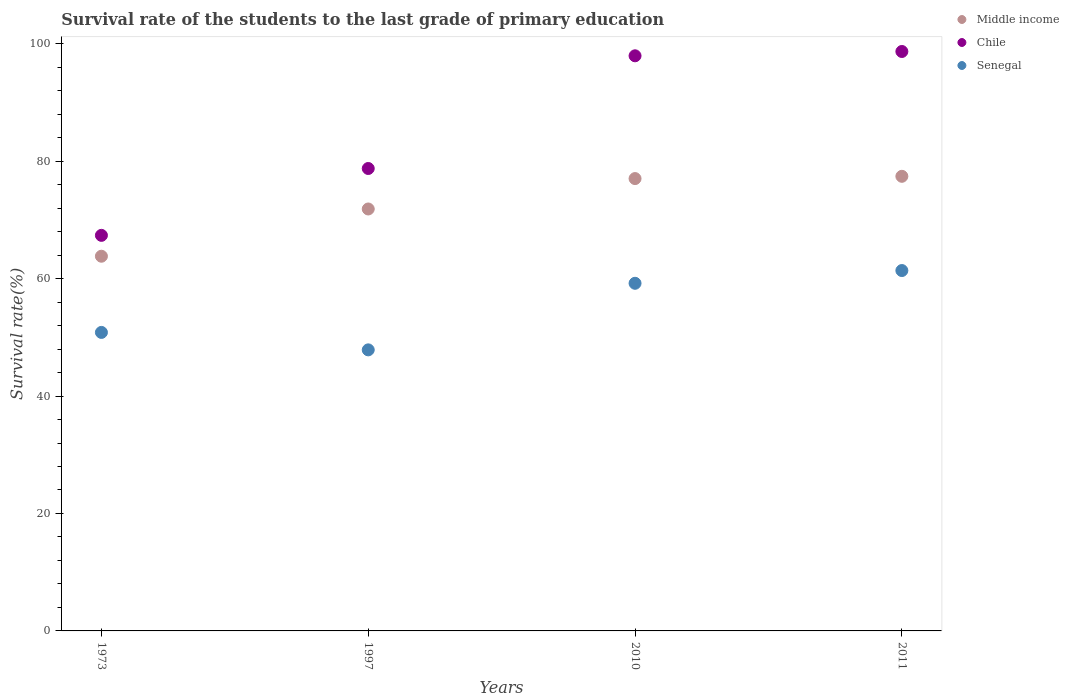What is the survival rate of the students in Middle income in 2010?
Offer a very short reply. 77.03. Across all years, what is the maximum survival rate of the students in Senegal?
Your answer should be very brief. 61.37. Across all years, what is the minimum survival rate of the students in Chile?
Your answer should be compact. 67.36. In which year was the survival rate of the students in Middle income maximum?
Provide a short and direct response. 2011. What is the total survival rate of the students in Senegal in the graph?
Offer a terse response. 219.25. What is the difference between the survival rate of the students in Chile in 1997 and that in 2010?
Offer a terse response. -19.19. What is the difference between the survival rate of the students in Chile in 1973 and the survival rate of the students in Middle income in 2010?
Provide a short and direct response. -9.67. What is the average survival rate of the students in Middle income per year?
Provide a succinct answer. 72.52. In the year 2011, what is the difference between the survival rate of the students in Senegal and survival rate of the students in Middle income?
Offer a terse response. -16.05. In how many years, is the survival rate of the students in Middle income greater than 44 %?
Ensure brevity in your answer.  4. What is the ratio of the survival rate of the students in Chile in 1997 to that in 2010?
Make the answer very short. 0.8. What is the difference between the highest and the second highest survival rate of the students in Chile?
Provide a short and direct response. 0.73. What is the difference between the highest and the lowest survival rate of the students in Senegal?
Keep it short and to the point. 13.51. In how many years, is the survival rate of the students in Middle income greater than the average survival rate of the students in Middle income taken over all years?
Your response must be concise. 2. Is the survival rate of the students in Chile strictly greater than the survival rate of the students in Middle income over the years?
Make the answer very short. Yes. Is the survival rate of the students in Chile strictly less than the survival rate of the students in Middle income over the years?
Make the answer very short. No. How many dotlines are there?
Ensure brevity in your answer.  3. What is the difference between two consecutive major ticks on the Y-axis?
Provide a short and direct response. 20. Does the graph contain grids?
Your answer should be compact. No. How are the legend labels stacked?
Your response must be concise. Vertical. What is the title of the graph?
Provide a succinct answer. Survival rate of the students to the last grade of primary education. Does "Tanzania" appear as one of the legend labels in the graph?
Provide a succinct answer. No. What is the label or title of the Y-axis?
Keep it short and to the point. Survival rate(%). What is the Survival rate(%) of Middle income in 1973?
Your answer should be compact. 63.8. What is the Survival rate(%) of Chile in 1973?
Offer a terse response. 67.36. What is the Survival rate(%) of Senegal in 1973?
Your answer should be compact. 50.83. What is the Survival rate(%) in Middle income in 1997?
Give a very brief answer. 71.85. What is the Survival rate(%) of Chile in 1997?
Your response must be concise. 78.74. What is the Survival rate(%) in Senegal in 1997?
Ensure brevity in your answer.  47.86. What is the Survival rate(%) of Middle income in 2010?
Make the answer very short. 77.03. What is the Survival rate(%) of Chile in 2010?
Your answer should be very brief. 97.93. What is the Survival rate(%) of Senegal in 2010?
Your response must be concise. 59.2. What is the Survival rate(%) of Middle income in 2011?
Keep it short and to the point. 77.41. What is the Survival rate(%) of Chile in 2011?
Ensure brevity in your answer.  98.67. What is the Survival rate(%) in Senegal in 2011?
Make the answer very short. 61.37. Across all years, what is the maximum Survival rate(%) in Middle income?
Give a very brief answer. 77.41. Across all years, what is the maximum Survival rate(%) in Chile?
Offer a terse response. 98.67. Across all years, what is the maximum Survival rate(%) in Senegal?
Ensure brevity in your answer.  61.37. Across all years, what is the minimum Survival rate(%) of Middle income?
Ensure brevity in your answer.  63.8. Across all years, what is the minimum Survival rate(%) in Chile?
Ensure brevity in your answer.  67.36. Across all years, what is the minimum Survival rate(%) of Senegal?
Ensure brevity in your answer.  47.86. What is the total Survival rate(%) of Middle income in the graph?
Make the answer very short. 290.09. What is the total Survival rate(%) in Chile in the graph?
Give a very brief answer. 342.7. What is the total Survival rate(%) of Senegal in the graph?
Your answer should be very brief. 219.25. What is the difference between the Survival rate(%) of Middle income in 1973 and that in 1997?
Your response must be concise. -8.05. What is the difference between the Survival rate(%) of Chile in 1973 and that in 1997?
Your answer should be compact. -11.38. What is the difference between the Survival rate(%) in Senegal in 1973 and that in 1997?
Give a very brief answer. 2.97. What is the difference between the Survival rate(%) of Middle income in 1973 and that in 2010?
Your answer should be compact. -13.22. What is the difference between the Survival rate(%) in Chile in 1973 and that in 2010?
Offer a very short reply. -30.58. What is the difference between the Survival rate(%) in Senegal in 1973 and that in 2010?
Keep it short and to the point. -8.36. What is the difference between the Survival rate(%) in Middle income in 1973 and that in 2011?
Ensure brevity in your answer.  -13.61. What is the difference between the Survival rate(%) of Chile in 1973 and that in 2011?
Keep it short and to the point. -31.31. What is the difference between the Survival rate(%) of Senegal in 1973 and that in 2011?
Provide a succinct answer. -10.54. What is the difference between the Survival rate(%) in Middle income in 1997 and that in 2010?
Keep it short and to the point. -5.18. What is the difference between the Survival rate(%) in Chile in 1997 and that in 2010?
Your answer should be very brief. -19.19. What is the difference between the Survival rate(%) in Senegal in 1997 and that in 2010?
Ensure brevity in your answer.  -11.34. What is the difference between the Survival rate(%) of Middle income in 1997 and that in 2011?
Provide a succinct answer. -5.56. What is the difference between the Survival rate(%) in Chile in 1997 and that in 2011?
Offer a terse response. -19.92. What is the difference between the Survival rate(%) in Senegal in 1997 and that in 2011?
Your answer should be very brief. -13.51. What is the difference between the Survival rate(%) in Middle income in 2010 and that in 2011?
Your answer should be very brief. -0.39. What is the difference between the Survival rate(%) of Chile in 2010 and that in 2011?
Make the answer very short. -0.73. What is the difference between the Survival rate(%) in Senegal in 2010 and that in 2011?
Make the answer very short. -2.17. What is the difference between the Survival rate(%) of Middle income in 1973 and the Survival rate(%) of Chile in 1997?
Give a very brief answer. -14.94. What is the difference between the Survival rate(%) of Middle income in 1973 and the Survival rate(%) of Senegal in 1997?
Ensure brevity in your answer.  15.94. What is the difference between the Survival rate(%) in Chile in 1973 and the Survival rate(%) in Senegal in 1997?
Provide a short and direct response. 19.5. What is the difference between the Survival rate(%) of Middle income in 1973 and the Survival rate(%) of Chile in 2010?
Offer a terse response. -34.13. What is the difference between the Survival rate(%) in Middle income in 1973 and the Survival rate(%) in Senegal in 2010?
Give a very brief answer. 4.61. What is the difference between the Survival rate(%) of Chile in 1973 and the Survival rate(%) of Senegal in 2010?
Offer a terse response. 8.16. What is the difference between the Survival rate(%) of Middle income in 1973 and the Survival rate(%) of Chile in 2011?
Offer a very short reply. -34.86. What is the difference between the Survival rate(%) in Middle income in 1973 and the Survival rate(%) in Senegal in 2011?
Your answer should be very brief. 2.44. What is the difference between the Survival rate(%) in Chile in 1973 and the Survival rate(%) in Senegal in 2011?
Provide a succinct answer. 5.99. What is the difference between the Survival rate(%) in Middle income in 1997 and the Survival rate(%) in Chile in 2010?
Make the answer very short. -26.08. What is the difference between the Survival rate(%) of Middle income in 1997 and the Survival rate(%) of Senegal in 2010?
Your response must be concise. 12.65. What is the difference between the Survival rate(%) of Chile in 1997 and the Survival rate(%) of Senegal in 2010?
Keep it short and to the point. 19.55. What is the difference between the Survival rate(%) in Middle income in 1997 and the Survival rate(%) in Chile in 2011?
Give a very brief answer. -26.82. What is the difference between the Survival rate(%) in Middle income in 1997 and the Survival rate(%) in Senegal in 2011?
Offer a terse response. 10.48. What is the difference between the Survival rate(%) of Chile in 1997 and the Survival rate(%) of Senegal in 2011?
Offer a terse response. 17.38. What is the difference between the Survival rate(%) in Middle income in 2010 and the Survival rate(%) in Chile in 2011?
Your answer should be compact. -21.64. What is the difference between the Survival rate(%) in Middle income in 2010 and the Survival rate(%) in Senegal in 2011?
Give a very brief answer. 15.66. What is the difference between the Survival rate(%) in Chile in 2010 and the Survival rate(%) in Senegal in 2011?
Provide a succinct answer. 36.57. What is the average Survival rate(%) of Middle income per year?
Ensure brevity in your answer.  72.52. What is the average Survival rate(%) of Chile per year?
Your response must be concise. 85.68. What is the average Survival rate(%) in Senegal per year?
Provide a succinct answer. 54.81. In the year 1973, what is the difference between the Survival rate(%) of Middle income and Survival rate(%) of Chile?
Provide a succinct answer. -3.55. In the year 1973, what is the difference between the Survival rate(%) of Middle income and Survival rate(%) of Senegal?
Provide a succinct answer. 12.97. In the year 1973, what is the difference between the Survival rate(%) in Chile and Survival rate(%) in Senegal?
Offer a very short reply. 16.53. In the year 1997, what is the difference between the Survival rate(%) of Middle income and Survival rate(%) of Chile?
Make the answer very short. -6.89. In the year 1997, what is the difference between the Survival rate(%) in Middle income and Survival rate(%) in Senegal?
Your response must be concise. 23.99. In the year 1997, what is the difference between the Survival rate(%) in Chile and Survival rate(%) in Senegal?
Provide a succinct answer. 30.88. In the year 2010, what is the difference between the Survival rate(%) of Middle income and Survival rate(%) of Chile?
Make the answer very short. -20.91. In the year 2010, what is the difference between the Survival rate(%) in Middle income and Survival rate(%) in Senegal?
Your response must be concise. 17.83. In the year 2010, what is the difference between the Survival rate(%) of Chile and Survival rate(%) of Senegal?
Provide a succinct answer. 38.74. In the year 2011, what is the difference between the Survival rate(%) in Middle income and Survival rate(%) in Chile?
Your answer should be very brief. -21.25. In the year 2011, what is the difference between the Survival rate(%) in Middle income and Survival rate(%) in Senegal?
Ensure brevity in your answer.  16.05. In the year 2011, what is the difference between the Survival rate(%) in Chile and Survival rate(%) in Senegal?
Your response must be concise. 37.3. What is the ratio of the Survival rate(%) in Middle income in 1973 to that in 1997?
Your response must be concise. 0.89. What is the ratio of the Survival rate(%) in Chile in 1973 to that in 1997?
Keep it short and to the point. 0.86. What is the ratio of the Survival rate(%) in Senegal in 1973 to that in 1997?
Your answer should be compact. 1.06. What is the ratio of the Survival rate(%) of Middle income in 1973 to that in 2010?
Keep it short and to the point. 0.83. What is the ratio of the Survival rate(%) of Chile in 1973 to that in 2010?
Provide a short and direct response. 0.69. What is the ratio of the Survival rate(%) in Senegal in 1973 to that in 2010?
Offer a terse response. 0.86. What is the ratio of the Survival rate(%) of Middle income in 1973 to that in 2011?
Your answer should be very brief. 0.82. What is the ratio of the Survival rate(%) in Chile in 1973 to that in 2011?
Your answer should be compact. 0.68. What is the ratio of the Survival rate(%) in Senegal in 1973 to that in 2011?
Offer a terse response. 0.83. What is the ratio of the Survival rate(%) of Middle income in 1997 to that in 2010?
Provide a short and direct response. 0.93. What is the ratio of the Survival rate(%) of Chile in 1997 to that in 2010?
Provide a short and direct response. 0.8. What is the ratio of the Survival rate(%) in Senegal in 1997 to that in 2010?
Give a very brief answer. 0.81. What is the ratio of the Survival rate(%) in Middle income in 1997 to that in 2011?
Offer a terse response. 0.93. What is the ratio of the Survival rate(%) of Chile in 1997 to that in 2011?
Provide a short and direct response. 0.8. What is the ratio of the Survival rate(%) of Senegal in 1997 to that in 2011?
Offer a very short reply. 0.78. What is the ratio of the Survival rate(%) in Middle income in 2010 to that in 2011?
Your response must be concise. 0.99. What is the ratio of the Survival rate(%) in Chile in 2010 to that in 2011?
Your response must be concise. 0.99. What is the ratio of the Survival rate(%) of Senegal in 2010 to that in 2011?
Offer a very short reply. 0.96. What is the difference between the highest and the second highest Survival rate(%) in Middle income?
Ensure brevity in your answer.  0.39. What is the difference between the highest and the second highest Survival rate(%) in Chile?
Provide a succinct answer. 0.73. What is the difference between the highest and the second highest Survival rate(%) in Senegal?
Ensure brevity in your answer.  2.17. What is the difference between the highest and the lowest Survival rate(%) in Middle income?
Your response must be concise. 13.61. What is the difference between the highest and the lowest Survival rate(%) of Chile?
Provide a short and direct response. 31.31. What is the difference between the highest and the lowest Survival rate(%) of Senegal?
Your answer should be compact. 13.51. 